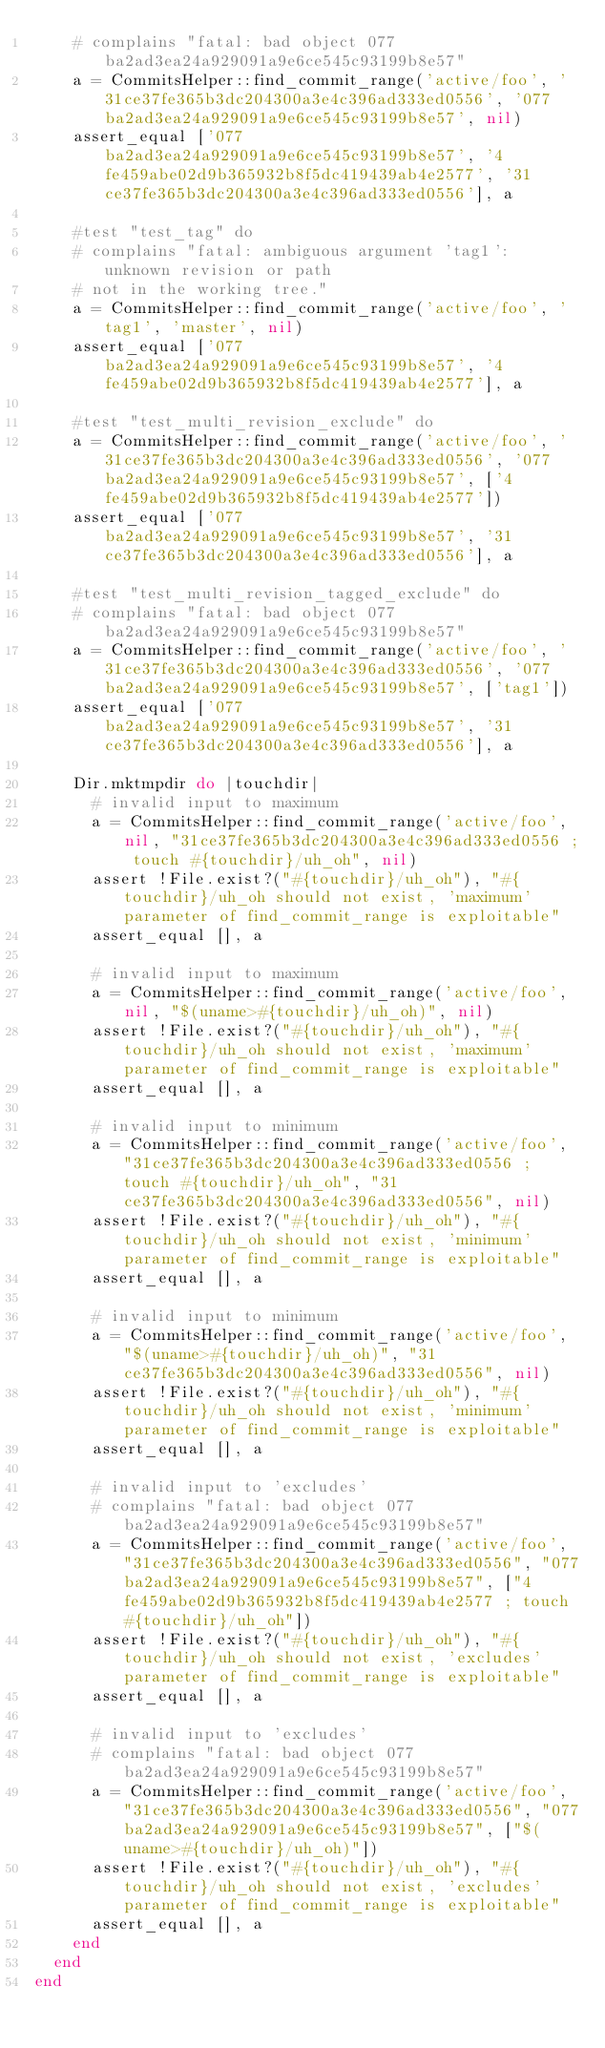Convert code to text. <code><loc_0><loc_0><loc_500><loc_500><_Ruby_>    # complains "fatal: bad object 077ba2ad3ea24a929091a9e6ce545c93199b8e57"
    a = CommitsHelper::find_commit_range('active/foo', '31ce37fe365b3dc204300a3e4c396ad333ed0556', '077ba2ad3ea24a929091a9e6ce545c93199b8e57', nil)
    assert_equal ['077ba2ad3ea24a929091a9e6ce545c93199b8e57', '4fe459abe02d9b365932b8f5dc419439ab4e2577', '31ce37fe365b3dc204300a3e4c396ad333ed0556'], a

    #test "test_tag" do
    # complains "fatal: ambiguous argument 'tag1': unknown revision or path
    # not in the working tree."
    a = CommitsHelper::find_commit_range('active/foo', 'tag1', 'master', nil)
    assert_equal ['077ba2ad3ea24a929091a9e6ce545c93199b8e57', '4fe459abe02d9b365932b8f5dc419439ab4e2577'], a

    #test "test_multi_revision_exclude" do
    a = CommitsHelper::find_commit_range('active/foo', '31ce37fe365b3dc204300a3e4c396ad333ed0556', '077ba2ad3ea24a929091a9e6ce545c93199b8e57', ['4fe459abe02d9b365932b8f5dc419439ab4e2577'])
    assert_equal ['077ba2ad3ea24a929091a9e6ce545c93199b8e57', '31ce37fe365b3dc204300a3e4c396ad333ed0556'], a

    #test "test_multi_revision_tagged_exclude" do
    # complains "fatal: bad object 077ba2ad3ea24a929091a9e6ce545c93199b8e57"
    a = CommitsHelper::find_commit_range('active/foo', '31ce37fe365b3dc204300a3e4c396ad333ed0556', '077ba2ad3ea24a929091a9e6ce545c93199b8e57', ['tag1'])
    assert_equal ['077ba2ad3ea24a929091a9e6ce545c93199b8e57', '31ce37fe365b3dc204300a3e4c396ad333ed0556'], a

    Dir.mktmpdir do |touchdir|
      # invalid input to maximum
      a = CommitsHelper::find_commit_range('active/foo', nil, "31ce37fe365b3dc204300a3e4c396ad333ed0556 ; touch #{touchdir}/uh_oh", nil)
      assert !File.exist?("#{touchdir}/uh_oh"), "#{touchdir}/uh_oh should not exist, 'maximum' parameter of find_commit_range is exploitable"
      assert_equal [], a

      # invalid input to maximum
      a = CommitsHelper::find_commit_range('active/foo', nil, "$(uname>#{touchdir}/uh_oh)", nil)
      assert !File.exist?("#{touchdir}/uh_oh"), "#{touchdir}/uh_oh should not exist, 'maximum' parameter of find_commit_range is exploitable"
      assert_equal [], a

      # invalid input to minimum
      a = CommitsHelper::find_commit_range('active/foo', "31ce37fe365b3dc204300a3e4c396ad333ed0556 ; touch #{touchdir}/uh_oh", "31ce37fe365b3dc204300a3e4c396ad333ed0556", nil)
      assert !File.exist?("#{touchdir}/uh_oh"), "#{touchdir}/uh_oh should not exist, 'minimum' parameter of find_commit_range is exploitable"
      assert_equal [], a

      # invalid input to minimum
      a = CommitsHelper::find_commit_range('active/foo', "$(uname>#{touchdir}/uh_oh)", "31ce37fe365b3dc204300a3e4c396ad333ed0556", nil)
      assert !File.exist?("#{touchdir}/uh_oh"), "#{touchdir}/uh_oh should not exist, 'minimum' parameter of find_commit_range is exploitable"
      assert_equal [], a

      # invalid input to 'excludes'
      # complains "fatal: bad object 077ba2ad3ea24a929091a9e6ce545c93199b8e57"
      a = CommitsHelper::find_commit_range('active/foo', "31ce37fe365b3dc204300a3e4c396ad333ed0556", "077ba2ad3ea24a929091a9e6ce545c93199b8e57", ["4fe459abe02d9b365932b8f5dc419439ab4e2577 ; touch #{touchdir}/uh_oh"])
      assert !File.exist?("#{touchdir}/uh_oh"), "#{touchdir}/uh_oh should not exist, 'excludes' parameter of find_commit_range is exploitable"
      assert_equal [], a

      # invalid input to 'excludes'
      # complains "fatal: bad object 077ba2ad3ea24a929091a9e6ce545c93199b8e57"
      a = CommitsHelper::find_commit_range('active/foo', "31ce37fe365b3dc204300a3e4c396ad333ed0556", "077ba2ad3ea24a929091a9e6ce545c93199b8e57", ["$(uname>#{touchdir}/uh_oh)"])
      assert !File.exist?("#{touchdir}/uh_oh"), "#{touchdir}/uh_oh should not exist, 'excludes' parameter of find_commit_range is exploitable"
      assert_equal [], a
    end
  end
end
</code> 